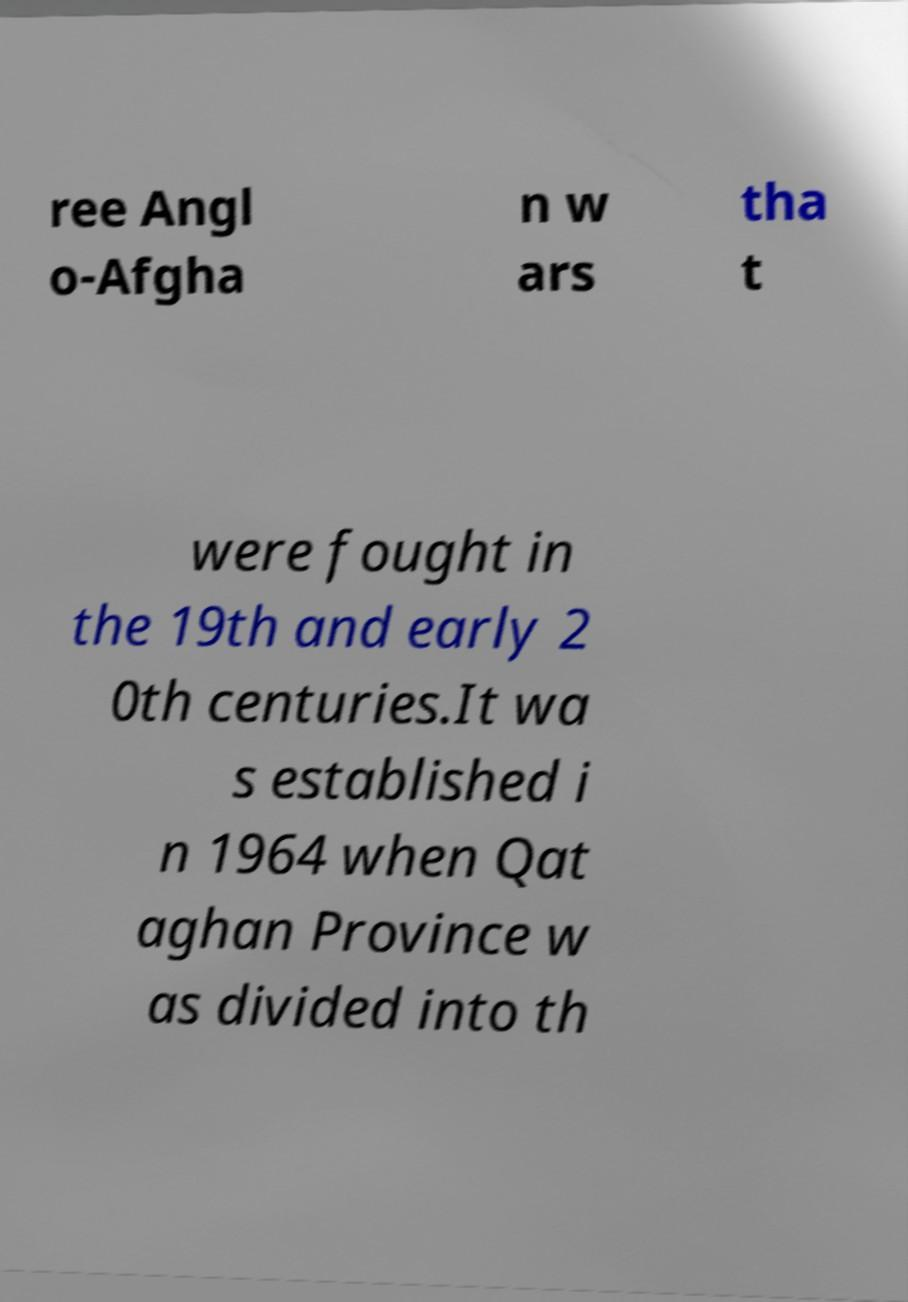Could you extract and type out the text from this image? ree Angl o-Afgha n w ars tha t were fought in the 19th and early 2 0th centuries.It wa s established i n 1964 when Qat aghan Province w as divided into th 